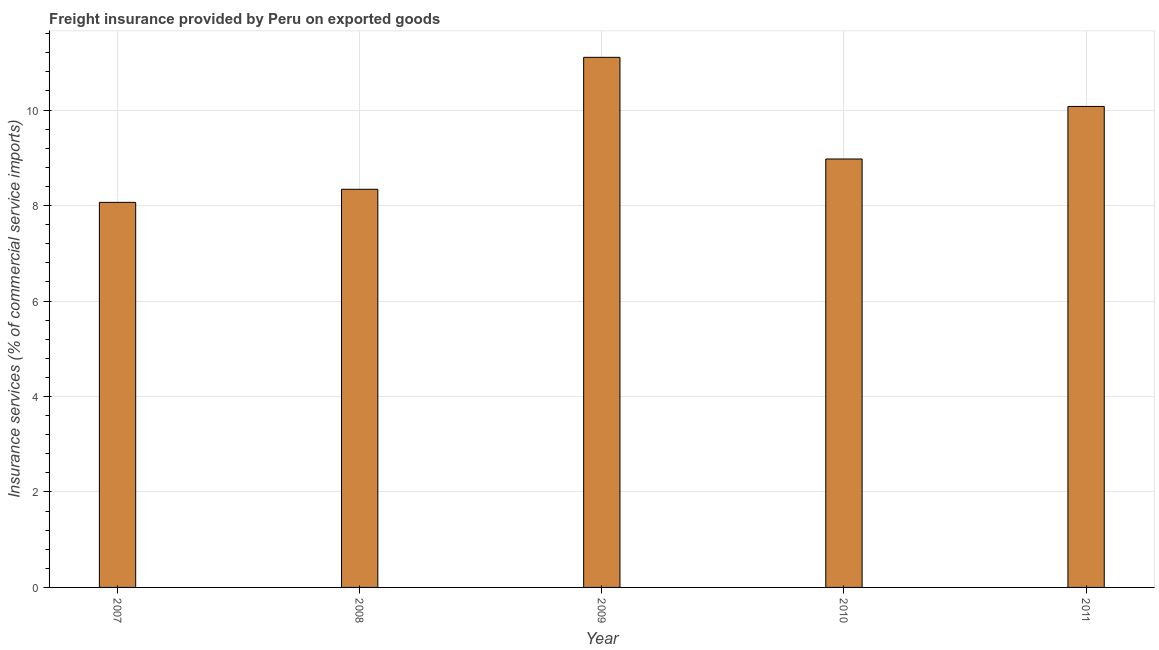What is the title of the graph?
Offer a terse response. Freight insurance provided by Peru on exported goods . What is the label or title of the Y-axis?
Your answer should be very brief. Insurance services (% of commercial service imports). What is the freight insurance in 2007?
Provide a short and direct response. 8.07. Across all years, what is the maximum freight insurance?
Your answer should be very brief. 11.1. Across all years, what is the minimum freight insurance?
Keep it short and to the point. 8.07. In which year was the freight insurance maximum?
Your response must be concise. 2009. What is the sum of the freight insurance?
Ensure brevity in your answer.  46.56. What is the difference between the freight insurance in 2007 and 2008?
Offer a very short reply. -0.27. What is the average freight insurance per year?
Your answer should be very brief. 9.31. What is the median freight insurance?
Keep it short and to the point. 8.98. Is the freight insurance in 2008 less than that in 2009?
Your answer should be compact. Yes. Is the difference between the freight insurance in 2007 and 2010 greater than the difference between any two years?
Make the answer very short. No. What is the difference between the highest and the lowest freight insurance?
Keep it short and to the point. 3.04. How many bars are there?
Give a very brief answer. 5. Are all the bars in the graph horizontal?
Provide a short and direct response. No. How many years are there in the graph?
Provide a succinct answer. 5. What is the Insurance services (% of commercial service imports) of 2007?
Provide a succinct answer. 8.07. What is the Insurance services (% of commercial service imports) of 2008?
Your answer should be very brief. 8.34. What is the Insurance services (% of commercial service imports) of 2009?
Your answer should be compact. 11.1. What is the Insurance services (% of commercial service imports) in 2010?
Provide a succinct answer. 8.98. What is the Insurance services (% of commercial service imports) of 2011?
Keep it short and to the point. 10.08. What is the difference between the Insurance services (% of commercial service imports) in 2007 and 2008?
Provide a succinct answer. -0.27. What is the difference between the Insurance services (% of commercial service imports) in 2007 and 2009?
Your answer should be very brief. -3.04. What is the difference between the Insurance services (% of commercial service imports) in 2007 and 2010?
Your response must be concise. -0.91. What is the difference between the Insurance services (% of commercial service imports) in 2007 and 2011?
Provide a short and direct response. -2.01. What is the difference between the Insurance services (% of commercial service imports) in 2008 and 2009?
Ensure brevity in your answer.  -2.76. What is the difference between the Insurance services (% of commercial service imports) in 2008 and 2010?
Your answer should be compact. -0.63. What is the difference between the Insurance services (% of commercial service imports) in 2008 and 2011?
Keep it short and to the point. -1.74. What is the difference between the Insurance services (% of commercial service imports) in 2009 and 2010?
Provide a succinct answer. 2.13. What is the difference between the Insurance services (% of commercial service imports) in 2009 and 2011?
Your response must be concise. 1.03. What is the difference between the Insurance services (% of commercial service imports) in 2010 and 2011?
Ensure brevity in your answer.  -1.1. What is the ratio of the Insurance services (% of commercial service imports) in 2007 to that in 2009?
Keep it short and to the point. 0.73. What is the ratio of the Insurance services (% of commercial service imports) in 2007 to that in 2010?
Keep it short and to the point. 0.9. What is the ratio of the Insurance services (% of commercial service imports) in 2007 to that in 2011?
Make the answer very short. 0.8. What is the ratio of the Insurance services (% of commercial service imports) in 2008 to that in 2009?
Your answer should be compact. 0.75. What is the ratio of the Insurance services (% of commercial service imports) in 2008 to that in 2010?
Your answer should be compact. 0.93. What is the ratio of the Insurance services (% of commercial service imports) in 2008 to that in 2011?
Offer a terse response. 0.83. What is the ratio of the Insurance services (% of commercial service imports) in 2009 to that in 2010?
Make the answer very short. 1.24. What is the ratio of the Insurance services (% of commercial service imports) in 2009 to that in 2011?
Your answer should be very brief. 1.1. What is the ratio of the Insurance services (% of commercial service imports) in 2010 to that in 2011?
Your answer should be very brief. 0.89. 